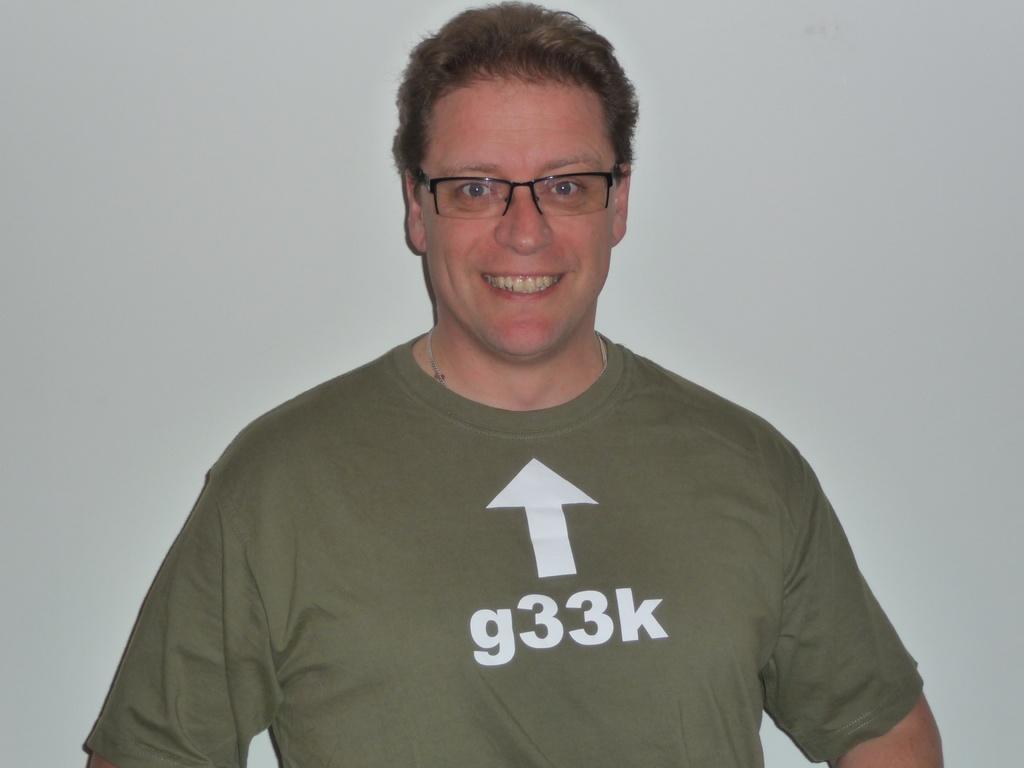What is the main subject of the image? The main subject of the image is a man. What can be observed about the man's appearance? The man is wearing spectacles. What is the man's facial expression in the image? The man is smiling. What is the color of the background in the image? The background of the image is white. What type of humor is the man using in the image? There is no indication of humor in the image; the man is simply smiling. What game is the man playing in the image? There is no game being played in the image; the man is just smiling and wearing spectacles. 